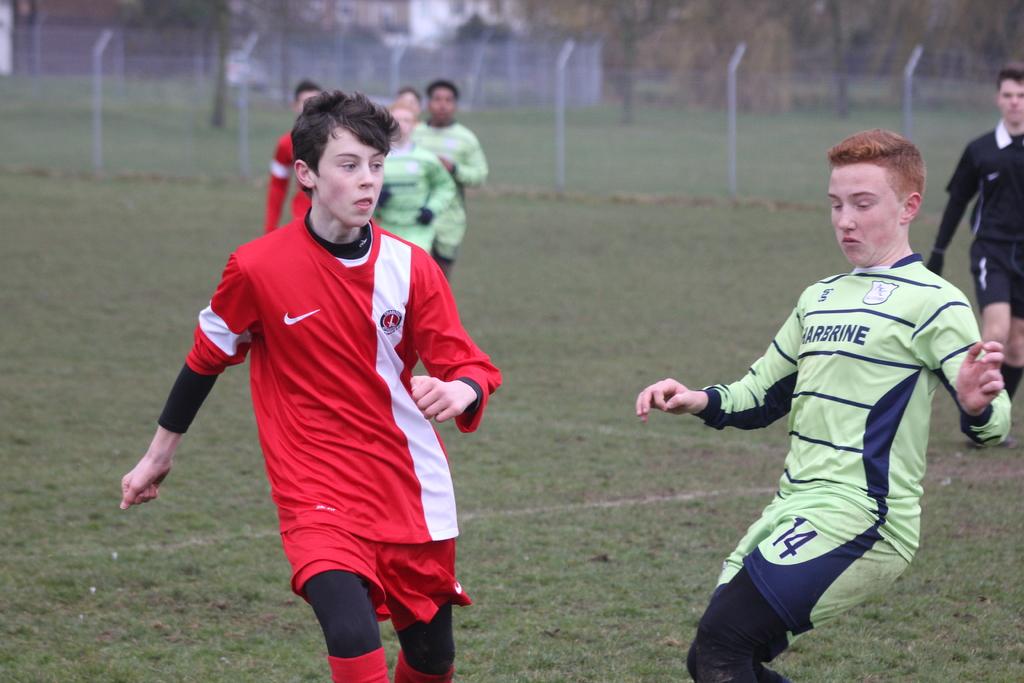What number is the kid in green?
Provide a succinct answer. 14. What is the last letter of the word on the green jersey kid?
Keep it short and to the point. E. 